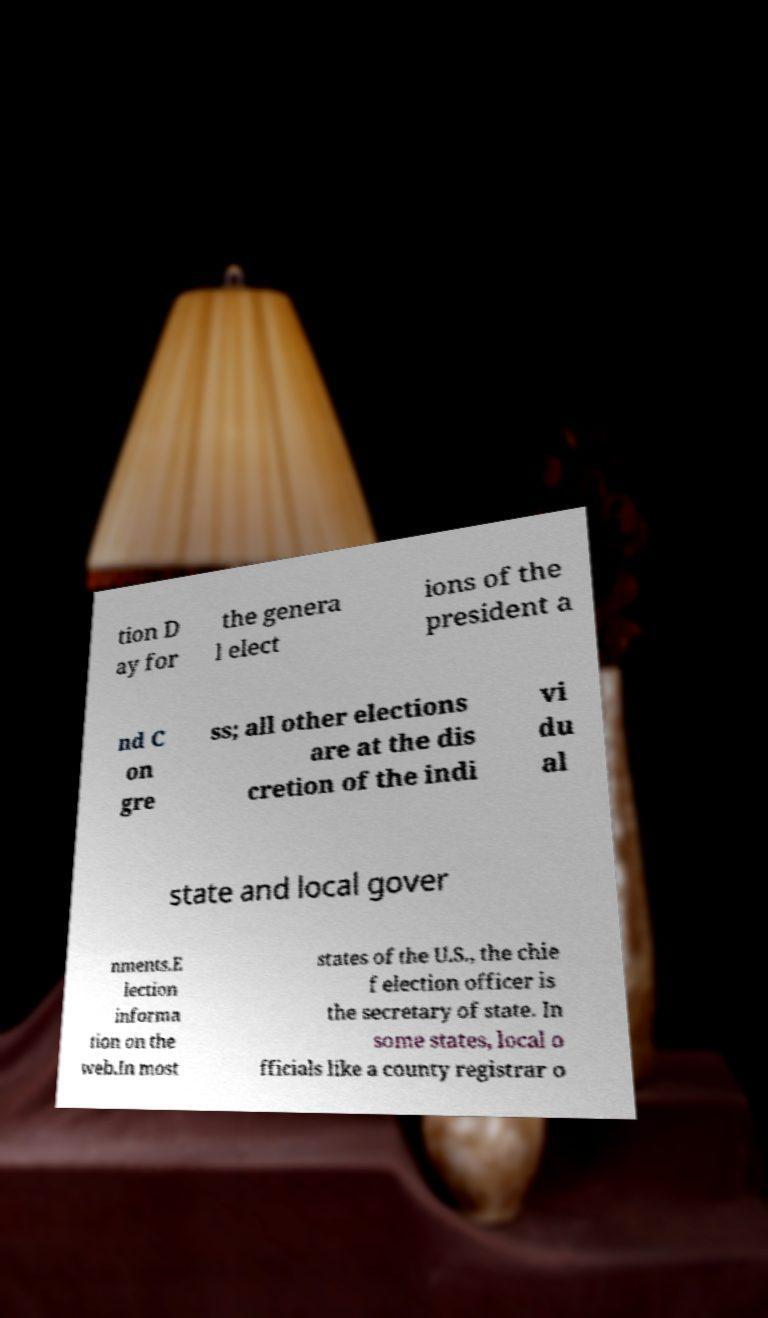What messages or text are displayed in this image? I need them in a readable, typed format. tion D ay for the genera l elect ions of the president a nd C on gre ss; all other elections are at the dis cretion of the indi vi du al state and local gover nments.E lection informa tion on the web.In most states of the U.S., the chie f election officer is the secretary of state. In some states, local o fficials like a county registrar o 